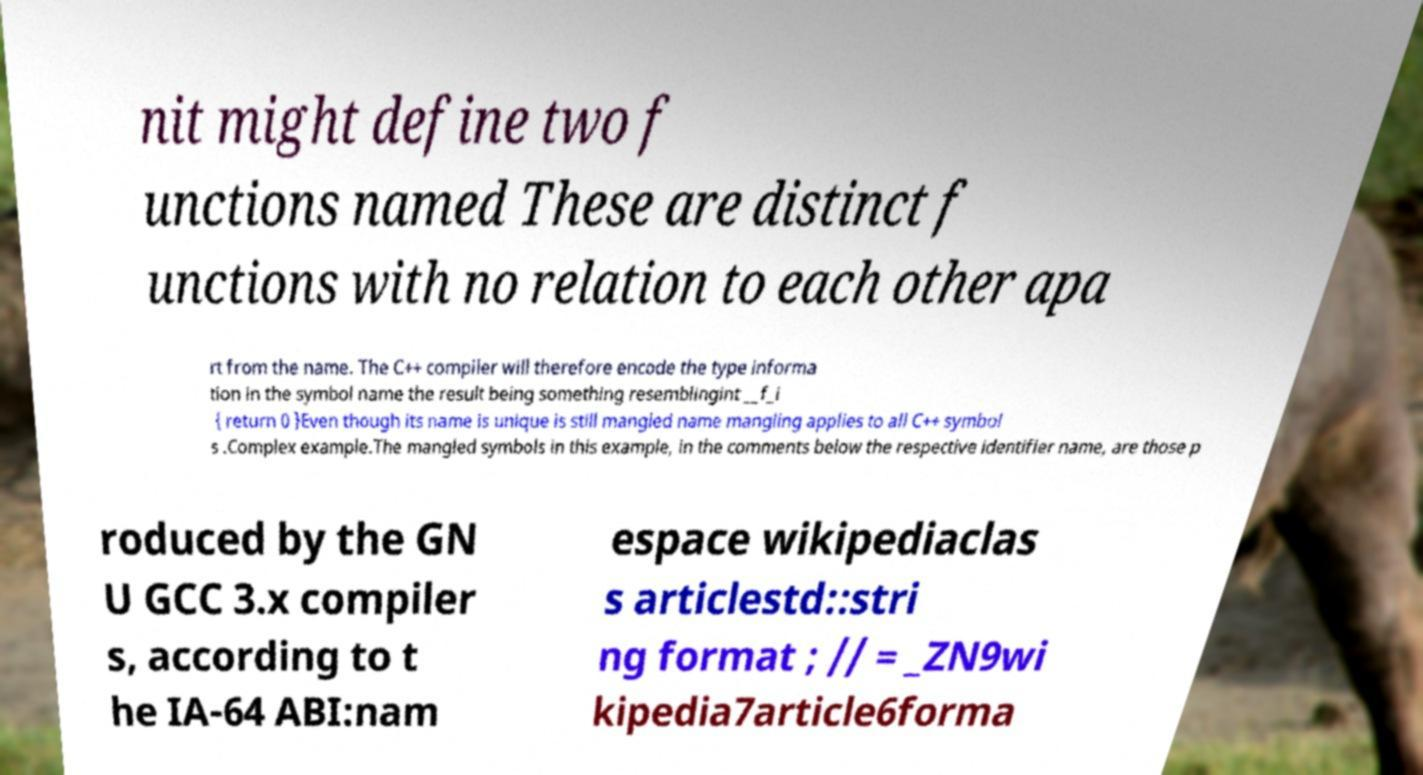Please read and relay the text visible in this image. What does it say? nit might define two f unctions named These are distinct f unctions with no relation to each other apa rt from the name. The C++ compiler will therefore encode the type informa tion in the symbol name the result being something resemblingint __f_i { return 0 }Even though its name is unique is still mangled name mangling applies to all C++ symbol s .Complex example.The mangled symbols in this example, in the comments below the respective identifier name, are those p roduced by the GN U GCC 3.x compiler s, according to t he IA-64 ABI:nam espace wikipediaclas s articlestd::stri ng format ; // = _ZN9wi kipedia7article6forma 